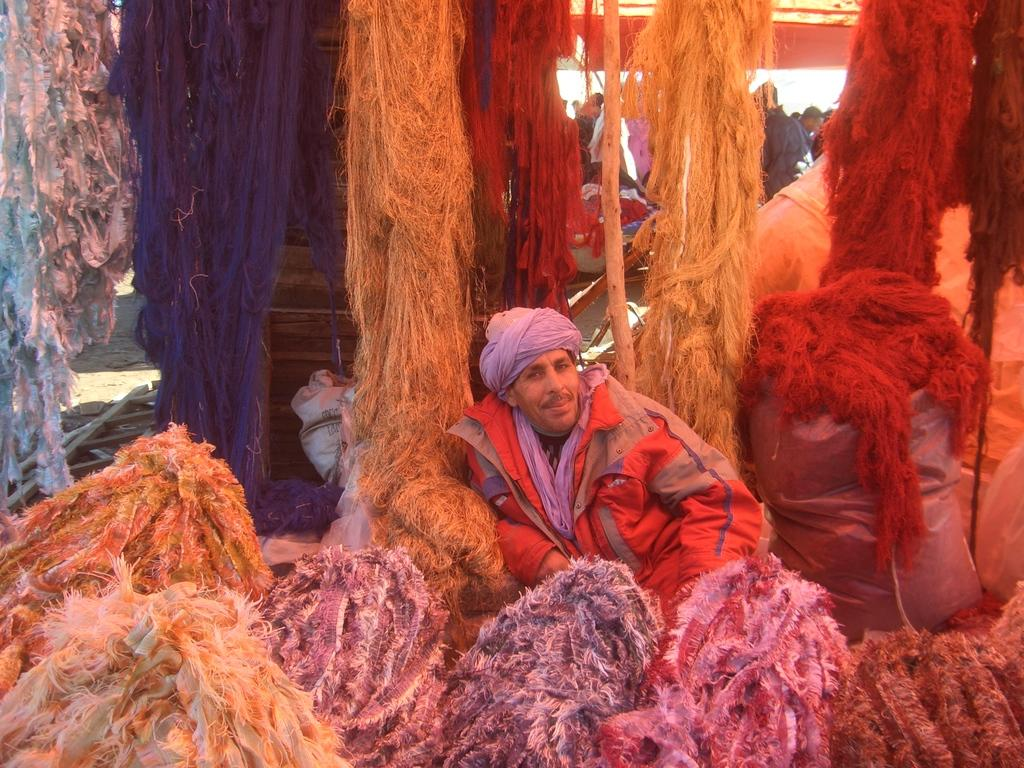What is the primary subject of the image? There is a person sitting in the image. What is surrounding the person in the image? There is a large quantity of wool around the person. What type of brass instrument is the person playing in the image? There is no brass instrument present in the image; the person is surrounded by wool. 